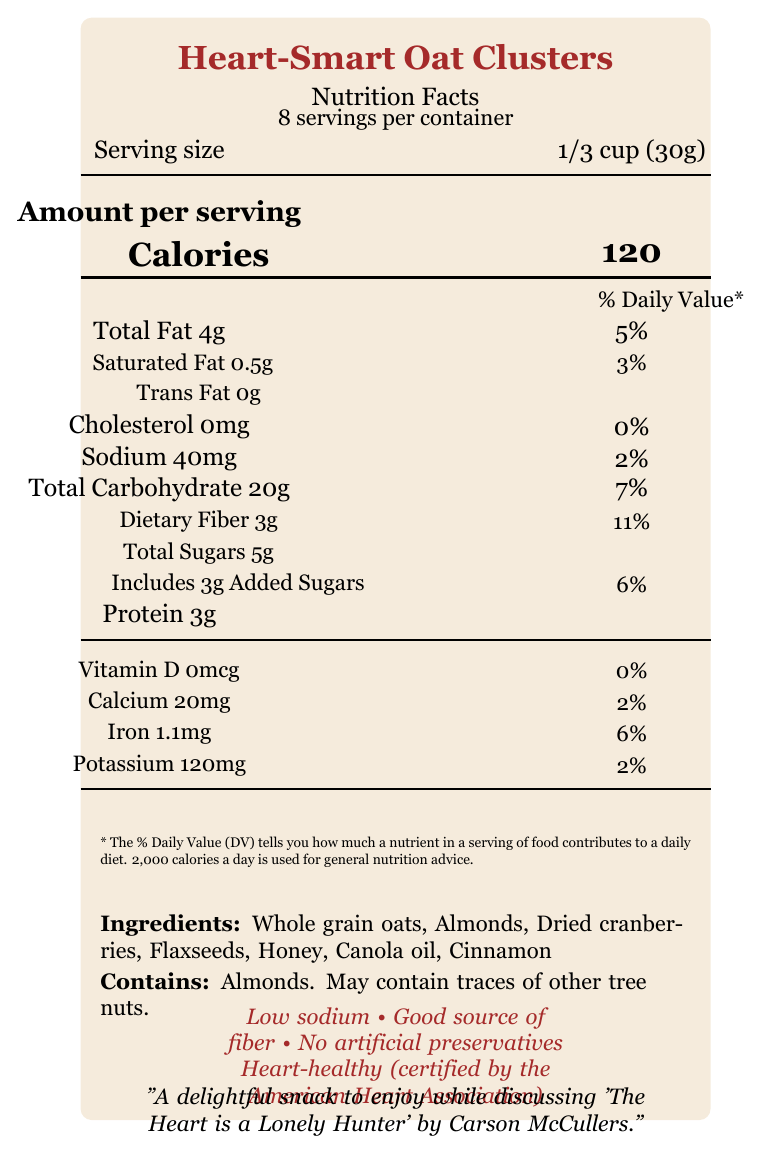What is the serving size of Heart-Smart Oat Clusters? The serving size is listed at the top part of the nutrition label as "Serving size: 1/3 cup (30g)".
Answer: 1/3 cup (30g) How many servings per container does Heart-Smart Oat Clusters have? This information is provided directly under the product name on the label, stating "8 servings per container".
Answer: About 8 How many calories are in one serving of Heart-Smart Oat Clusters? The calorie content per serving is highlighted in the middle of the label under "Amount per serving" as "Calories 120".
Answer: 120 calories What is the total fat content in one serving of Heart-Smart Oat Clusters? The total fat content is noted under "Total Fat" on the label as "Total Fat 4g".
Answer: 4g What percentage of the daily value for saturated fat does one serving of Heart-Smart Oat Clusters provide? This information is listed below the total fat content as "Saturated Fat 0.5g" and "3%".
Answer: 3% How much dietary fiber is in a serving of Heart-Smart Oat Clusters? The dietary fiber content is noted on the label as "Dietary Fiber 3g".
Answer: 3g Which of the following ingredients are NOT included in Heart-Smart Oat Clusters? A. Whole grain oats B. Almonds C. Chocolate chips D. Dried cranberries The ingredients listed are whole grain oats, almonds, dried cranberries, flaxseeds, honey, canola oil, and cinnamon. Chocolate chips are not mentioned.
Answer: C. Chocolate chips What health claims are made about Heart-Smart Oat Clusters? A. Rich in potassium B. Low sodium C. High in vitamin C D. Contains artificial preservatives The health claims stated are "Low sodium", "Good source of fiber", "No artificial preservatives", and "Heart-healthy (certified by the American Heart Association)". Options A and C are incorrect.
Answer: B. Low sodium Does Heart-Smart Oat Clusters contain any trans fat? The label clearly states "Trans Fat 0g" indicating there is no trans fat in the product.
Answer: No Summarize the main details provided by the Nutrition Facts label of Heart-Smart Oat Clusters. This summary encapsulates the key nutritional content, serving information, and health benefits of the Heart-Smart Oat Clusters as presented on the label.
Answer: The Heart-Smart Oat Clusters snacks are a heart-healthy option certified by the American Heart Association, with low sodium, no artificial preservatives, and a good source of fiber. Each serving size is 1/3 cup (30g) with about 8 servings per container. A serving contains 120 calories, 4g of total fat, 0.5g of saturated fat, no trans fat, 40mg of sodium, 20g of total carbohydrates (including 3g dietary fiber and 5g total sugars with 3g added sugars), and 3g of protein. The product contains almonds and may contain traces of other tree nuts. What is the main source of protein in Heart-Smart Oat Clusters? The label lists ingredients but does not specify which ingredient is the primary source of protein.
Answer: Cannot be determined What is the iron content in a serving of Heart-Smart Oat Clusters? The iron content is listed in the nutrient details on the label as "Iron 1.1mg" providing 6% of the daily value.
Answer: 1.1mg Is Heart-Smart Oat Clusters an acceptable snack option for individuals looking to reduce their cholesterol intake? The label states that per serving there is "Cholesterol 0mg" meaning it does not contribute to cholesterol intake.
Answer: Yes 